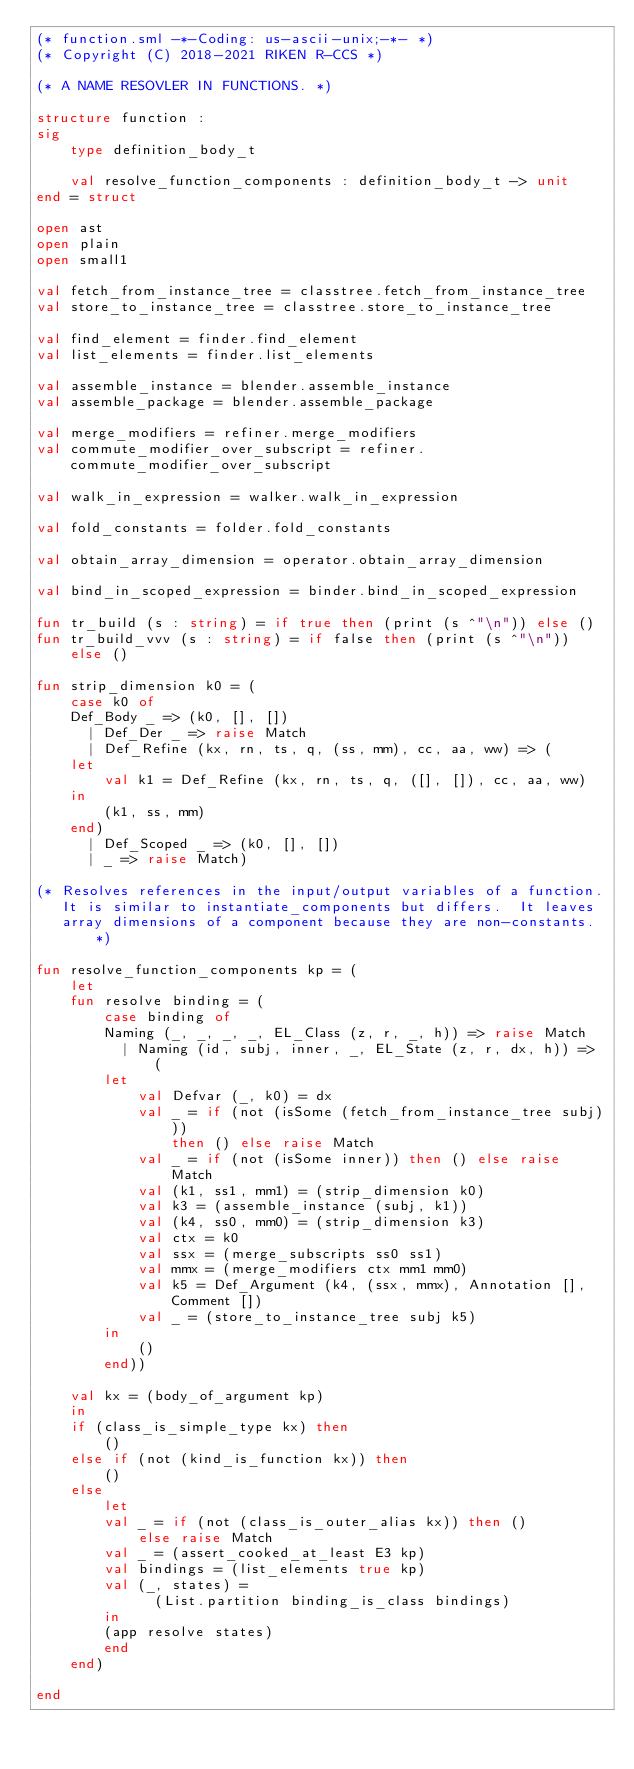Convert code to text. <code><loc_0><loc_0><loc_500><loc_500><_SML_>(* function.sml -*-Coding: us-ascii-unix;-*- *)
(* Copyright (C) 2018-2021 RIKEN R-CCS *)

(* A NAME RESOVLER IN FUNCTIONS. *)

structure function :
sig
    type definition_body_t

    val resolve_function_components : definition_body_t -> unit
end = struct

open ast
open plain
open small1

val fetch_from_instance_tree = classtree.fetch_from_instance_tree
val store_to_instance_tree = classtree.store_to_instance_tree

val find_element = finder.find_element
val list_elements = finder.list_elements

val assemble_instance = blender.assemble_instance
val assemble_package = blender.assemble_package

val merge_modifiers = refiner.merge_modifiers
val commute_modifier_over_subscript = refiner.commute_modifier_over_subscript

val walk_in_expression = walker.walk_in_expression

val fold_constants = folder.fold_constants

val obtain_array_dimension = operator.obtain_array_dimension

val bind_in_scoped_expression = binder.bind_in_scoped_expression

fun tr_build (s : string) = if true then (print (s ^"\n")) else ()
fun tr_build_vvv (s : string) = if false then (print (s ^"\n")) else ()

fun strip_dimension k0 = (
    case k0 of
	Def_Body _ => (k0, [], [])
      | Def_Der _ => raise Match
      | Def_Refine (kx, rn, ts, q, (ss, mm), cc, aa, ww) => (
	let
	    val k1 = Def_Refine (kx, rn, ts, q, ([], []), cc, aa, ww)
	in
	    (k1, ss, mm)
	end)
      | Def_Scoped _ => (k0, [], [])
      | _ => raise Match)

(* Resolves references in the input/output variables of a function.
   It is similar to instantiate_components but differs.  It leaves
   array dimensions of a component because they are non-constants. *)

fun resolve_function_components kp = (
    let
	fun resolve binding = (
	    case binding of
		Naming (_, _, _, _, EL_Class (z, r, _, h)) => raise Match
	      | Naming (id, subj, inner, _, EL_State (z, r, dx, h)) => (
		let
		    val Defvar (_, k0) = dx
		    val _ = if (not (isSome (fetch_from_instance_tree subj)))
			    then () else raise Match
		    val _ = if (not (isSome inner)) then () else raise Match
		    val (k1, ss1, mm1) = (strip_dimension k0)
		    val k3 = (assemble_instance (subj, k1))
		    val (k4, ss0, mm0) = (strip_dimension k3)
		    val ctx = k0
		    val ssx = (merge_subscripts ss0 ss1)
		    val mmx = (merge_modifiers ctx mm1 mm0)
		    val k5 = Def_Argument (k4, (ssx, mmx), Annotation [], Comment [])
		    val _ = (store_to_instance_tree subj k5)
		in
		    ()
		end))

	val kx = (body_of_argument kp)
    in
	if (class_is_simple_type kx) then
	    ()
	else if (not (kind_is_function kx)) then
	    ()
	else
	    let
		val _ = if (not (class_is_outer_alias kx)) then ()
			else raise Match
		val _ = (assert_cooked_at_least E3 kp)
		val bindings = (list_elements true kp)
		val (_, states) =
		      (List.partition binding_is_class bindings)
	    in
		(app resolve states)
	    end
    end)

end
</code> 